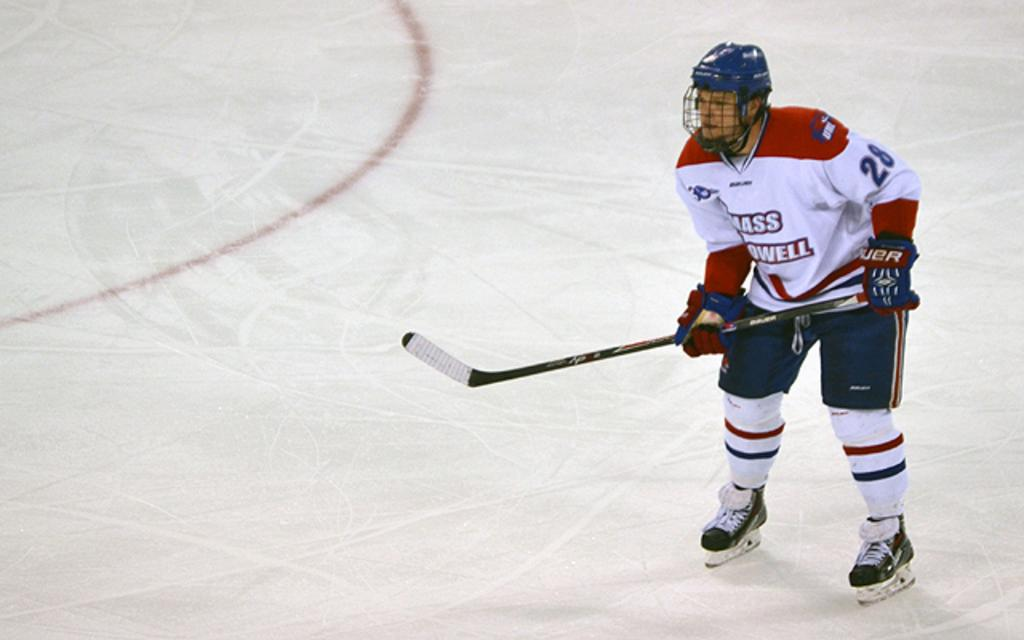Who or what is on the right side of the image? There is a person on the right side of the image. What is the person wearing? The person is wearing a colorful dress. What is the person holding in the image? The person is holding a stick. What protective gear is the person wearing? The person is wearing a helmet. What type of clothing is visible on the floor? The gloves are visible on the floor. What type of cemetery can be seen in the background of the image? There is no cemetery present in the image; it features a person wearing a helmet and holding a stick. Is the queen mentioned or depicted in the image? There is no mention or depiction of a queen in the image. 